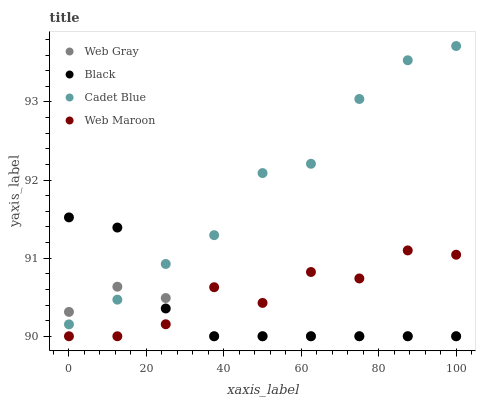Does Web Gray have the minimum area under the curve?
Answer yes or no. Yes. Does Cadet Blue have the maximum area under the curve?
Answer yes or no. Yes. Does Web Maroon have the minimum area under the curve?
Answer yes or no. No. Does Web Maroon have the maximum area under the curve?
Answer yes or no. No. Is Web Gray the smoothest?
Answer yes or no. Yes. Is Web Maroon the roughest?
Answer yes or no. Yes. Is Web Maroon the smoothest?
Answer yes or no. No. Is Web Gray the roughest?
Answer yes or no. No. Does Web Maroon have the lowest value?
Answer yes or no. Yes. Does Cadet Blue have the highest value?
Answer yes or no. Yes. Does Web Maroon have the highest value?
Answer yes or no. No. Is Web Maroon less than Cadet Blue?
Answer yes or no. Yes. Is Cadet Blue greater than Web Maroon?
Answer yes or no. Yes. Does Web Gray intersect Black?
Answer yes or no. Yes. Is Web Gray less than Black?
Answer yes or no. No. Is Web Gray greater than Black?
Answer yes or no. No. Does Web Maroon intersect Cadet Blue?
Answer yes or no. No. 